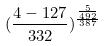<formula> <loc_0><loc_0><loc_500><loc_500>( \frac { 4 - 1 2 7 } { 3 3 2 } ) ^ { \frac { \frac { 5 } { 4 9 2 } } { 3 8 7 } }</formula> 